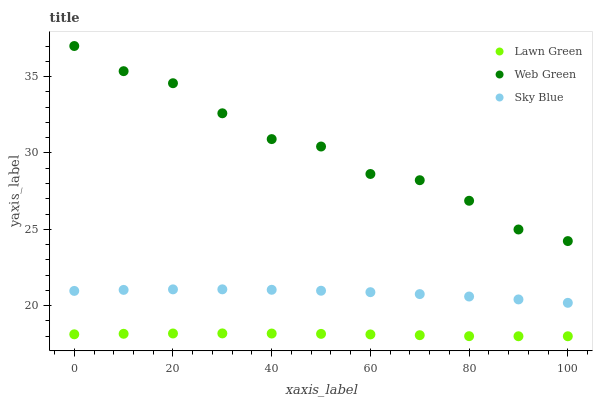Does Lawn Green have the minimum area under the curve?
Answer yes or no. Yes. Does Web Green have the maximum area under the curve?
Answer yes or no. Yes. Does Sky Blue have the minimum area under the curve?
Answer yes or no. No. Does Sky Blue have the maximum area under the curve?
Answer yes or no. No. Is Lawn Green the smoothest?
Answer yes or no. Yes. Is Web Green the roughest?
Answer yes or no. Yes. Is Sky Blue the smoothest?
Answer yes or no. No. Is Sky Blue the roughest?
Answer yes or no. No. Does Lawn Green have the lowest value?
Answer yes or no. Yes. Does Sky Blue have the lowest value?
Answer yes or no. No. Does Web Green have the highest value?
Answer yes or no. Yes. Does Sky Blue have the highest value?
Answer yes or no. No. Is Lawn Green less than Sky Blue?
Answer yes or no. Yes. Is Web Green greater than Sky Blue?
Answer yes or no. Yes. Does Lawn Green intersect Sky Blue?
Answer yes or no. No. 